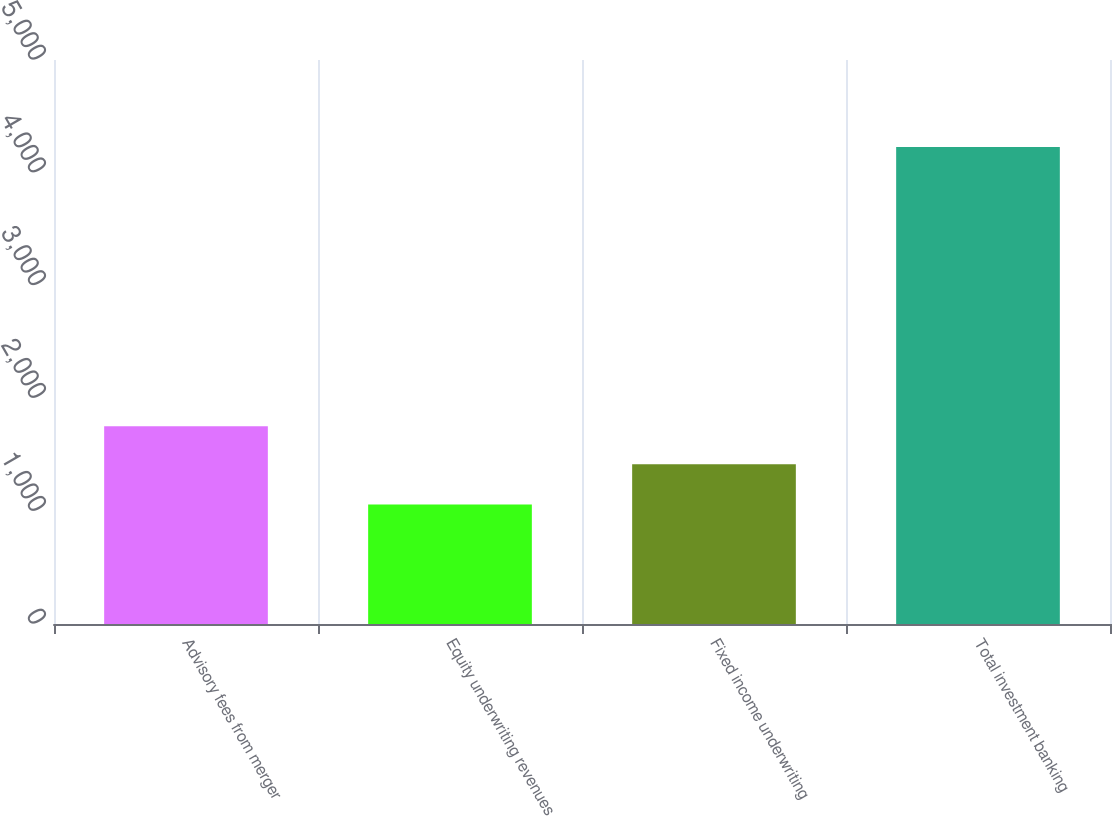Convert chart to OTSL. <chart><loc_0><loc_0><loc_500><loc_500><bar_chart><fcel>Advisory fees from merger<fcel>Equity underwriting revenues<fcel>Fixed income underwriting<fcel>Total investment banking<nl><fcel>1753<fcel>1059<fcel>1416<fcel>4228<nl></chart> 